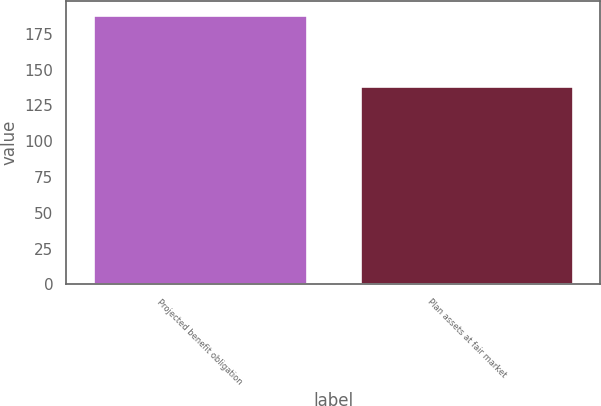Convert chart to OTSL. <chart><loc_0><loc_0><loc_500><loc_500><bar_chart><fcel>Projected benefit obligation<fcel>Plan assets at fair market<nl><fcel>188.4<fcel>138.5<nl></chart> 